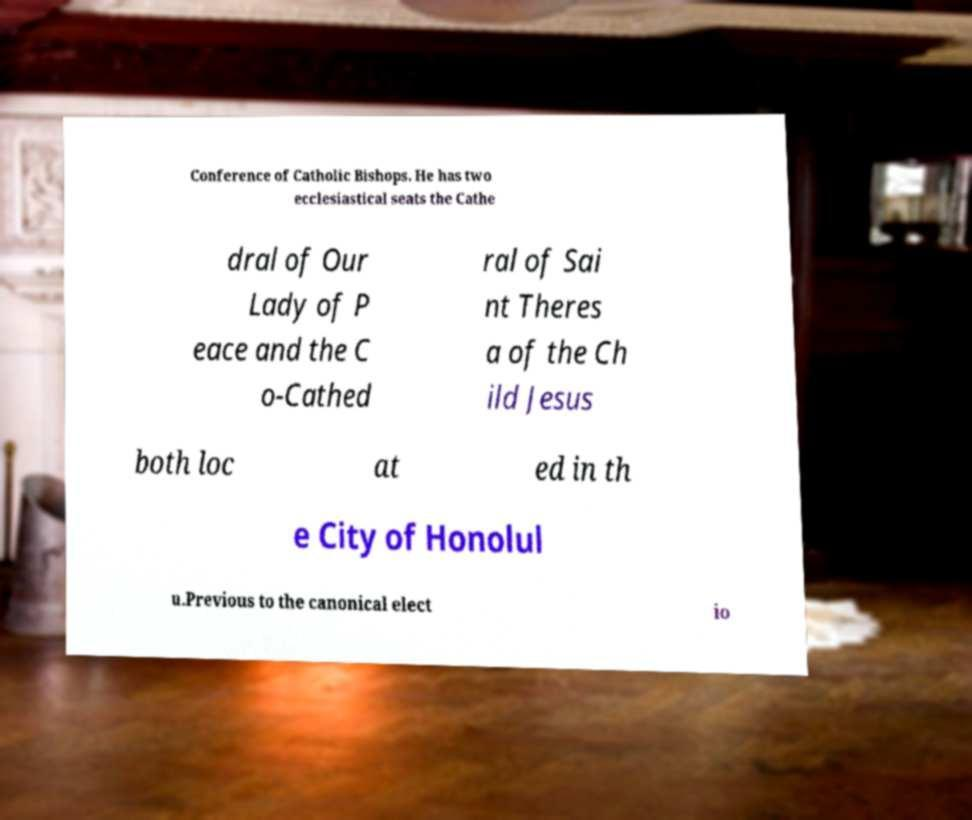Can you accurately transcribe the text from the provided image for me? Conference of Catholic Bishops. He has two ecclesiastical seats the Cathe dral of Our Lady of P eace and the C o-Cathed ral of Sai nt Theres a of the Ch ild Jesus both loc at ed in th e City of Honolul u.Previous to the canonical elect io 